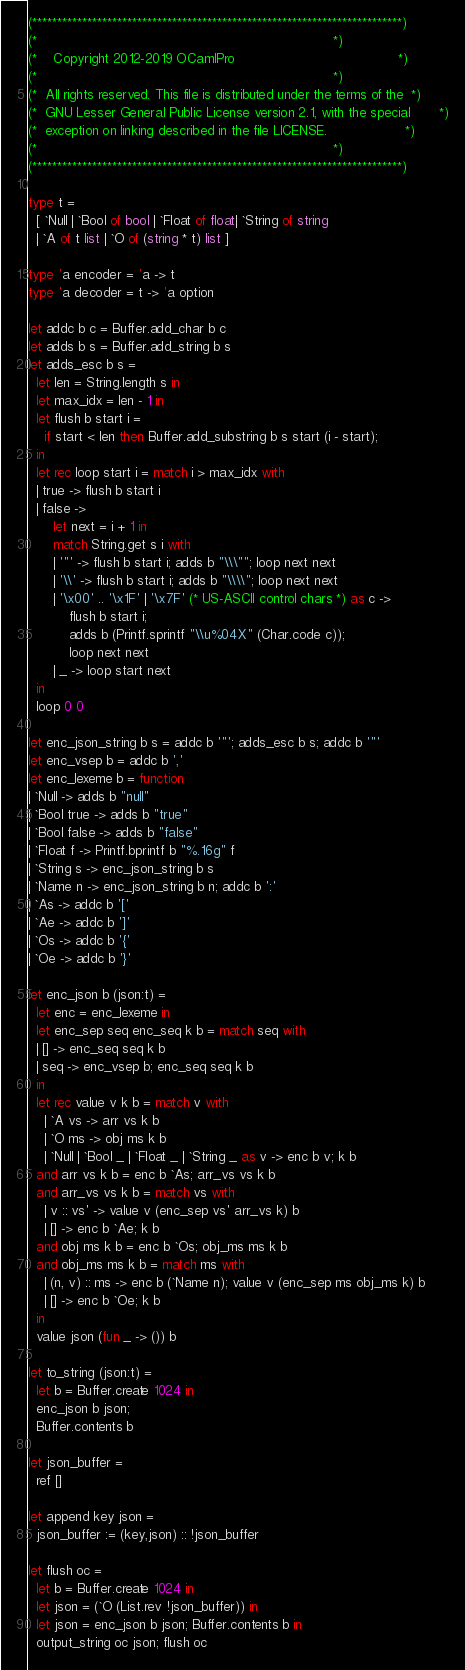Convert code to text. <code><loc_0><loc_0><loc_500><loc_500><_OCaml_>(**************************************************************************)
(*                                                                        *)
(*    Copyright 2012-2019 OCamlPro                                        *)
(*                                                                        *)
(*  All rights reserved. This file is distributed under the terms of the  *)
(*  GNU Lesser General Public License version 2.1, with the special       *)
(*  exception on linking described in the file LICENSE.                   *)
(*                                                                        *)
(**************************************************************************)

type t =
  [ `Null | `Bool of bool | `Float of float| `String of string
  | `A of t list | `O of (string * t) list ]

type 'a encoder = 'a -> t
type 'a decoder = t -> 'a option

let addc b c = Buffer.add_char b c
let adds b s = Buffer.add_string b s
let adds_esc b s =
  let len = String.length s in
  let max_idx = len - 1 in
  let flush b start i =
    if start < len then Buffer.add_substring b s start (i - start);
  in
  let rec loop start i = match i > max_idx with
  | true -> flush b start i
  | false ->
      let next = i + 1 in
      match String.get s i with
      | '"' -> flush b start i; adds b "\\\""; loop next next
      | '\\' -> flush b start i; adds b "\\\\"; loop next next
      | '\x00' .. '\x1F' | '\x7F' (* US-ASCII control chars *) as c ->
          flush b start i;
          adds b (Printf.sprintf "\\u%04X" (Char.code c));
          loop next next
      | _ -> loop start next
  in
  loop 0 0

let enc_json_string b s = addc b '"'; adds_esc b s; addc b '"'
let enc_vsep b = addc b ','
let enc_lexeme b = function
| `Null -> adds b "null"
| `Bool true -> adds b "true"
| `Bool false -> adds b "false"
| `Float f -> Printf.bprintf b "%.16g" f
| `String s -> enc_json_string b s
| `Name n -> enc_json_string b n; addc b ':'
| `As -> addc b '['
| `Ae -> addc b ']'
| `Os -> addc b '{'
| `Oe -> addc b '}'

let enc_json b (json:t) =
  let enc = enc_lexeme in
  let enc_sep seq enc_seq k b = match seq with
  | [] -> enc_seq seq k b
  | seq -> enc_vsep b; enc_seq seq k b
  in
  let rec value v k b = match v with
    | `A vs -> arr vs k b
    | `O ms -> obj ms k b
    | `Null | `Bool _ | `Float _ | `String _ as v -> enc b v; k b
  and arr vs k b = enc b `As; arr_vs vs k b
  and arr_vs vs k b = match vs with
    | v :: vs' -> value v (enc_sep vs' arr_vs k) b
    | [] -> enc b `Ae; k b
  and obj ms k b = enc b `Os; obj_ms ms k b
  and obj_ms ms k b = match ms with
    | (n, v) :: ms -> enc b (`Name n); value v (enc_sep ms obj_ms k) b
    | [] -> enc b `Oe; k b
  in
  value json (fun _ -> ()) b

let to_string (json:t) =
  let b = Buffer.create 1024 in
  enc_json b json;
  Buffer.contents b

let json_buffer =
  ref []

let append key json =
  json_buffer := (key,json) :: !json_buffer

let flush oc =
  let b = Buffer.create 1024 in
  let json = (`O (List.rev !json_buffer)) in
  let json = enc_json b json; Buffer.contents b in
  output_string oc json; flush oc
</code> 